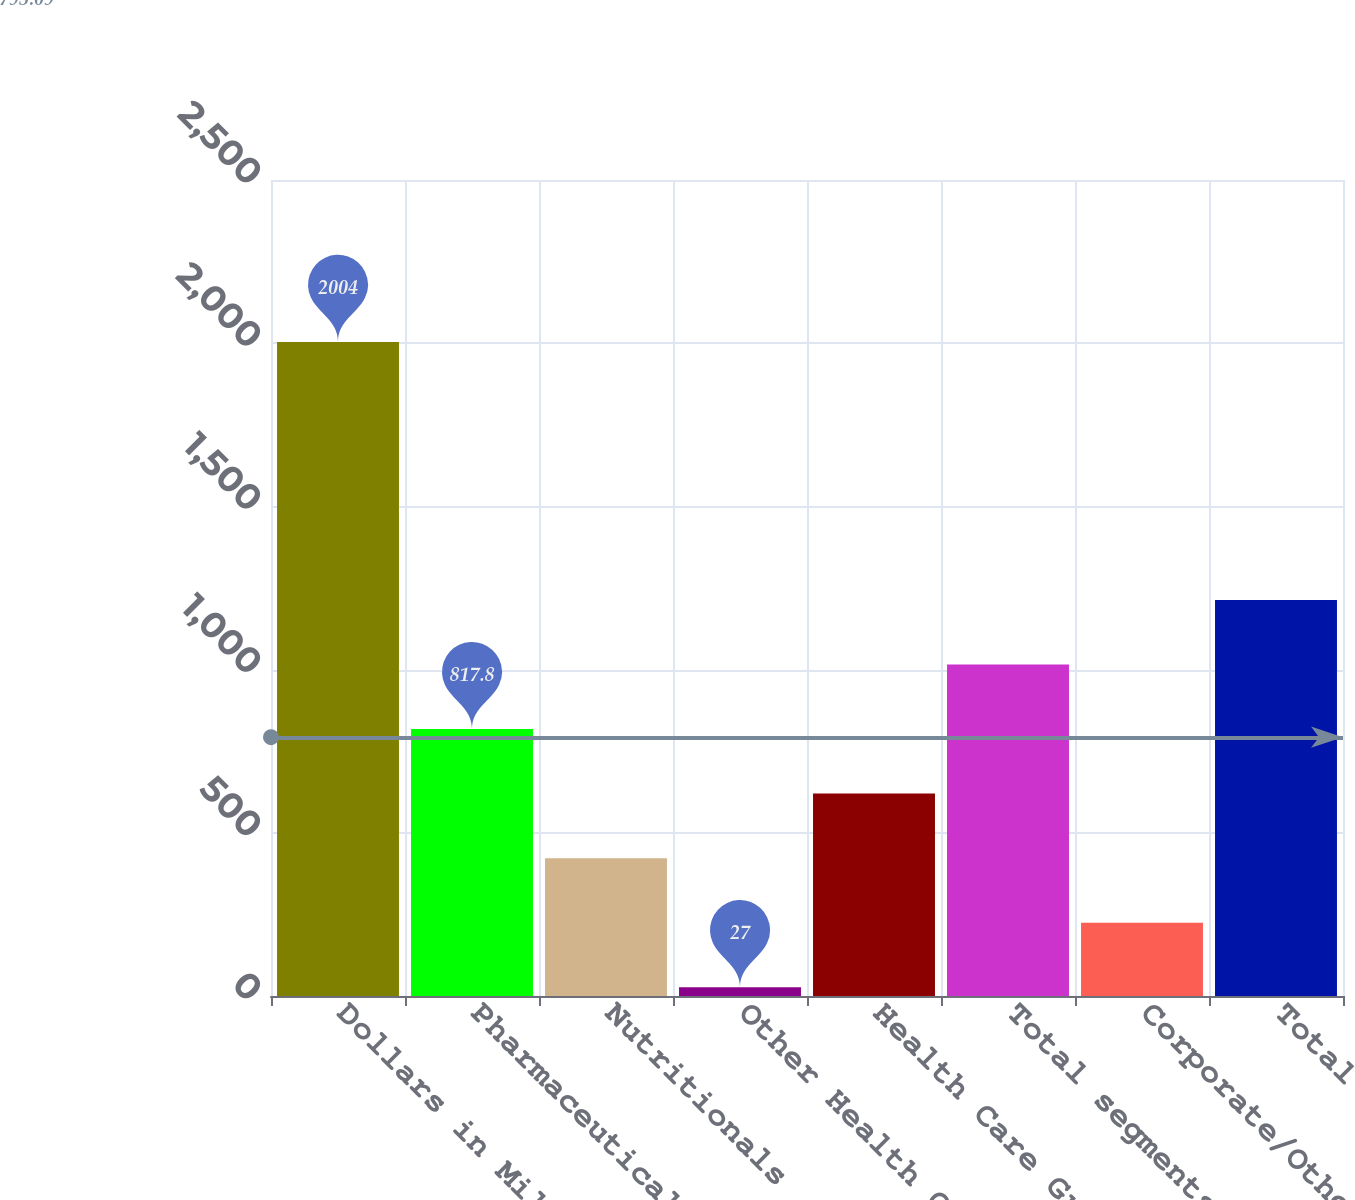<chart> <loc_0><loc_0><loc_500><loc_500><bar_chart><fcel>Dollars in Millions<fcel>Pharmaceuticals<fcel>Nutritionals<fcel>Other Health Care<fcel>Health Care Group<fcel>Total segments<fcel>Corporate/Other<fcel>Total<nl><fcel>2004<fcel>817.8<fcel>422.4<fcel>27<fcel>620.1<fcel>1015.5<fcel>224.7<fcel>1213.2<nl></chart> 